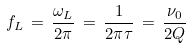<formula> <loc_0><loc_0><loc_500><loc_500>f _ { L } \, = \, \frac { \omega _ { L } } { 2 \pi } \, = \, \frac { 1 } { 2 \pi \tau } \, = \, \frac { \nu _ { 0 } } { 2 Q }</formula> 